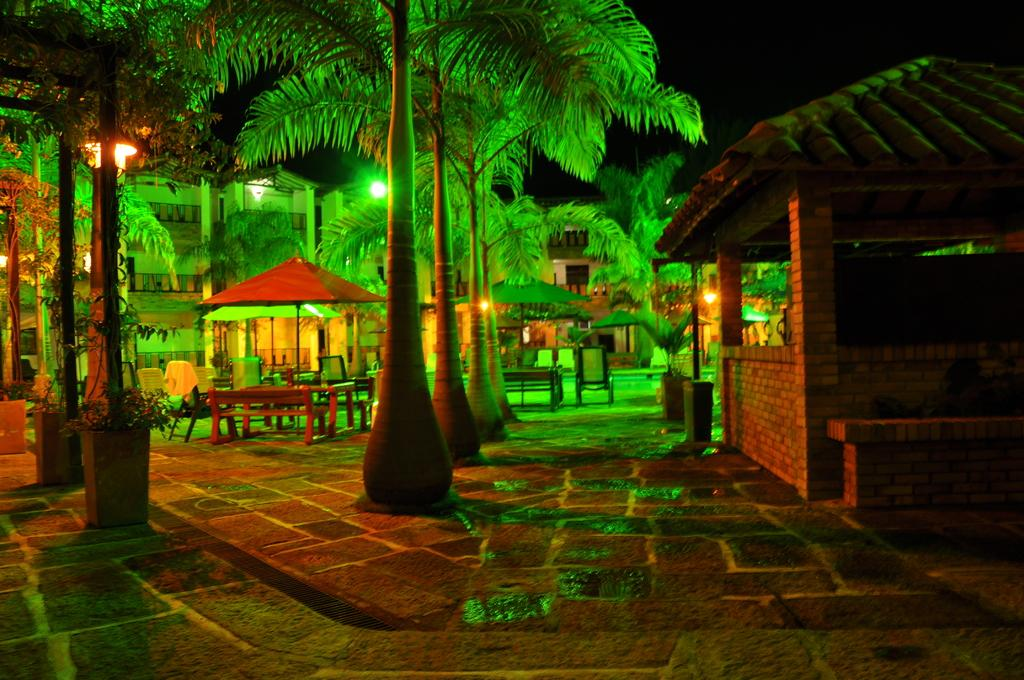What objects are present in the image for protection from the rain? There are umbrellas in the image for protection from the rain. What type of seating is available in the image? There are benches and chairs in the image for seating. What type of vegetation is present in the image? There are trees and plants in the image. What type of path is visible in the image? There is a path in the image. What type of lighting is present in the image? There are lights in the image. What type of structure is visible in the background of the image? There is a building visible in the background of the image. How would you describe the lighting conditions in the background of the image? The background view is dark. How many trucks are parked near the building in the image? There are no trucks visible in the image. What type of musical instrument is being played by the sheep in the image? There are no sheep or musical instruments present in the image. 